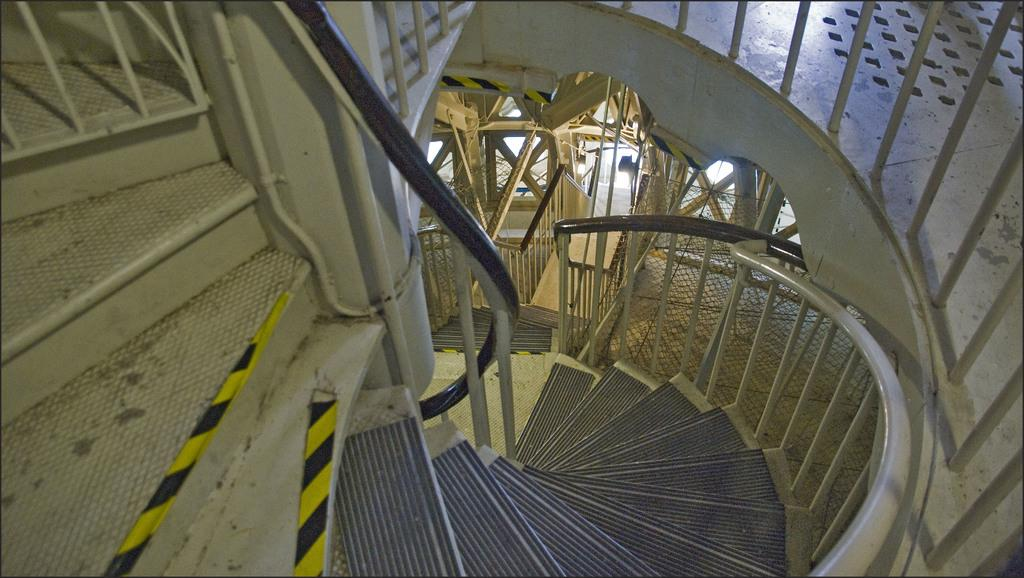What type of structure can be seen in the image? There are stairs in the image. To which building do the stairs belong? The stairs belong to a building. How much salt is sprinkled on the beef in the image? There is no beef or salt present in the image; it only features stairs and a building. 